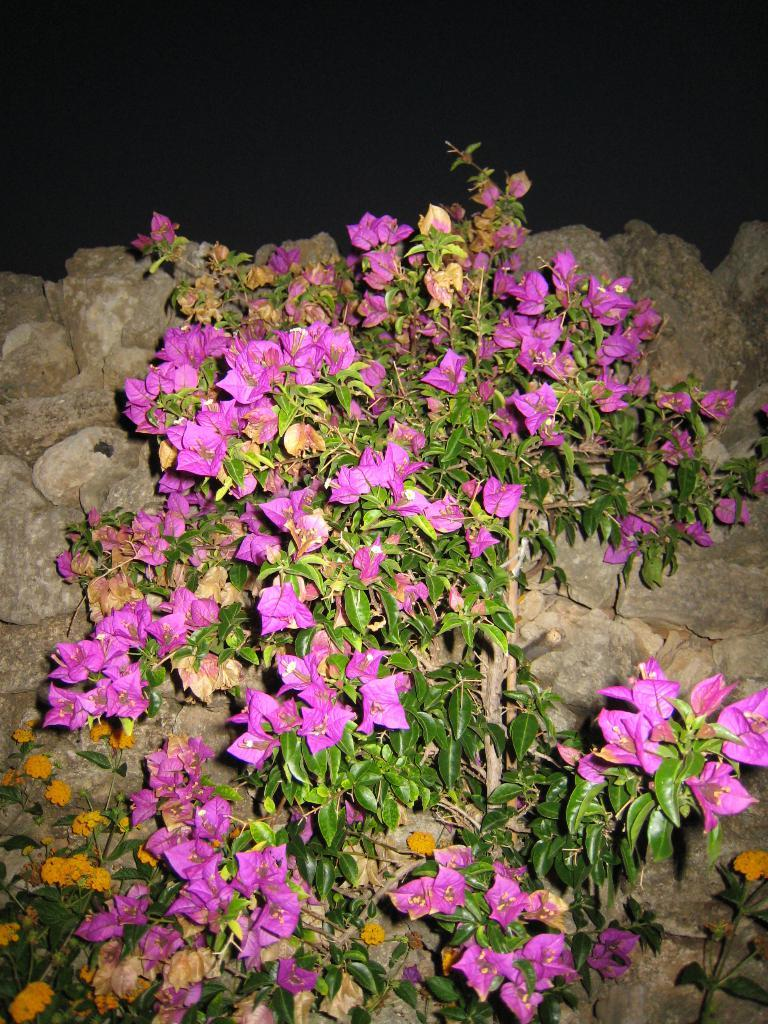What type of plant is in the image? There is a plant in the image with pink flowers. Can you describe the flowers on the plant? The flowers on the plant are pink. What other flowers can be seen in the image? There are orange flowers at the bottom of the image. What can be seen in the background of the image? There are stones and soil in the background of the image. What type of bells can be heard ringing in the image? There are no bells present in the image, and therefore no sound can be heard. 